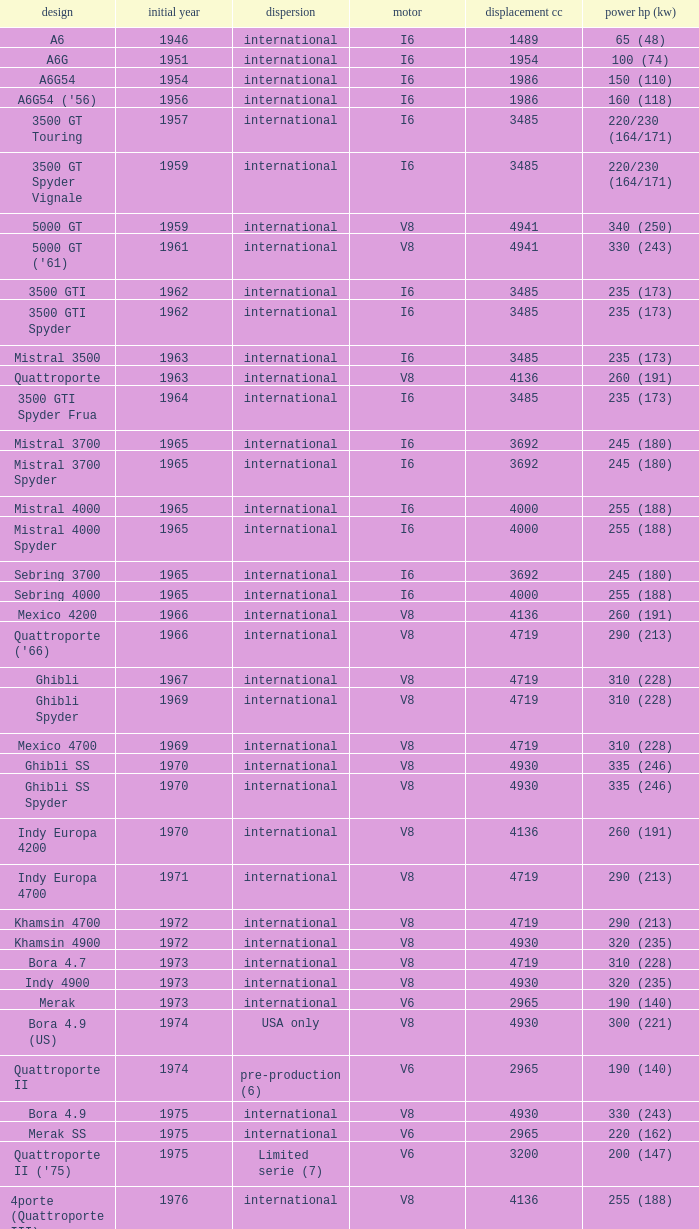What is Power HP (kW), when First Year is greater than 1965, when Distribution is "International", when Engine is V6 Biturbo, and when Model is "425"? 200 (147). 